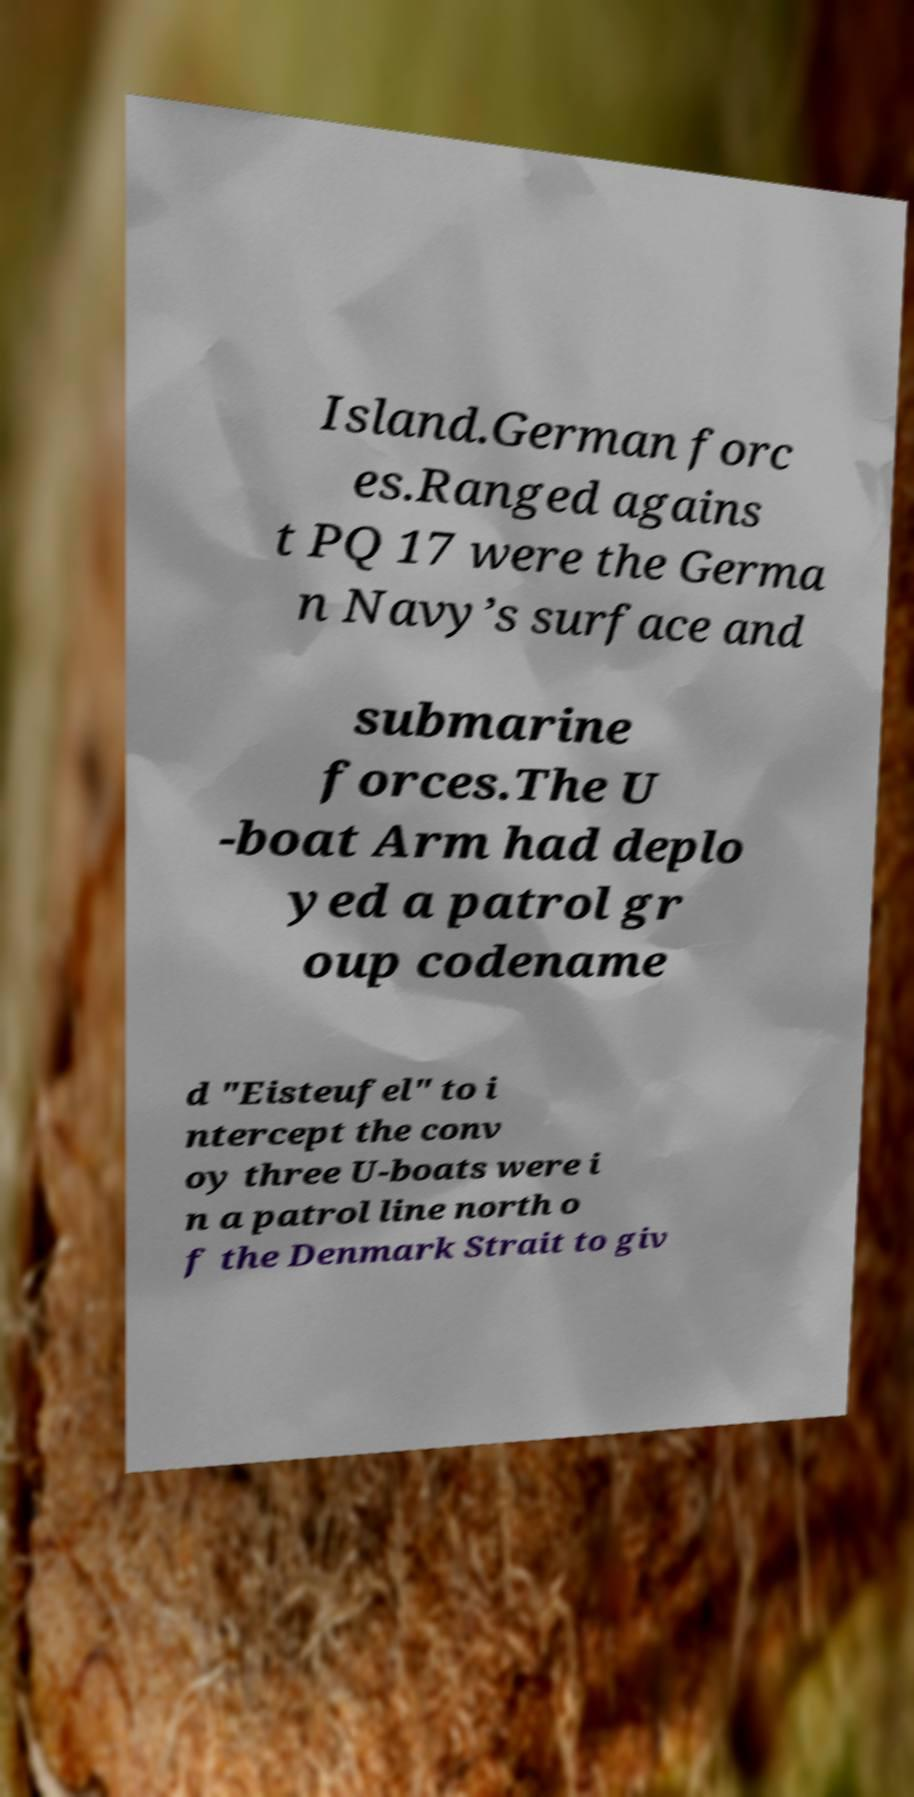What messages or text are displayed in this image? I need them in a readable, typed format. Island.German forc es.Ranged agains t PQ 17 were the Germa n Navy’s surface and submarine forces.The U -boat Arm had deplo yed a patrol gr oup codename d "Eisteufel" to i ntercept the conv oy three U-boats were i n a patrol line north o f the Denmark Strait to giv 